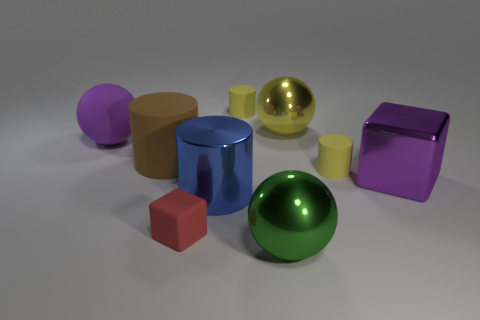How many big objects are to the left of the big brown cylinder and behind the purple rubber thing?
Keep it short and to the point. 0. Are there more big cylinders behind the metal block than big metal balls that are on the left side of the big blue metallic cylinder?
Ensure brevity in your answer.  Yes. What size is the brown matte object?
Your answer should be compact. Large. Are there any yellow metal things that have the same shape as the large blue metal thing?
Ensure brevity in your answer.  No. There is a red matte object; is it the same shape as the big thing behind the rubber sphere?
Offer a terse response. No. There is a rubber object that is left of the green metal ball and on the right side of the tiny cube; how big is it?
Offer a terse response. Small. How many purple cubes are there?
Your answer should be compact. 1. What material is the brown cylinder that is the same size as the green metallic sphere?
Provide a succinct answer. Rubber. Are there any red rubber objects that have the same size as the purple shiny object?
Provide a succinct answer. No. Does the ball to the left of the blue cylinder have the same color as the cube that is on the right side of the large green metallic object?
Offer a terse response. Yes. 